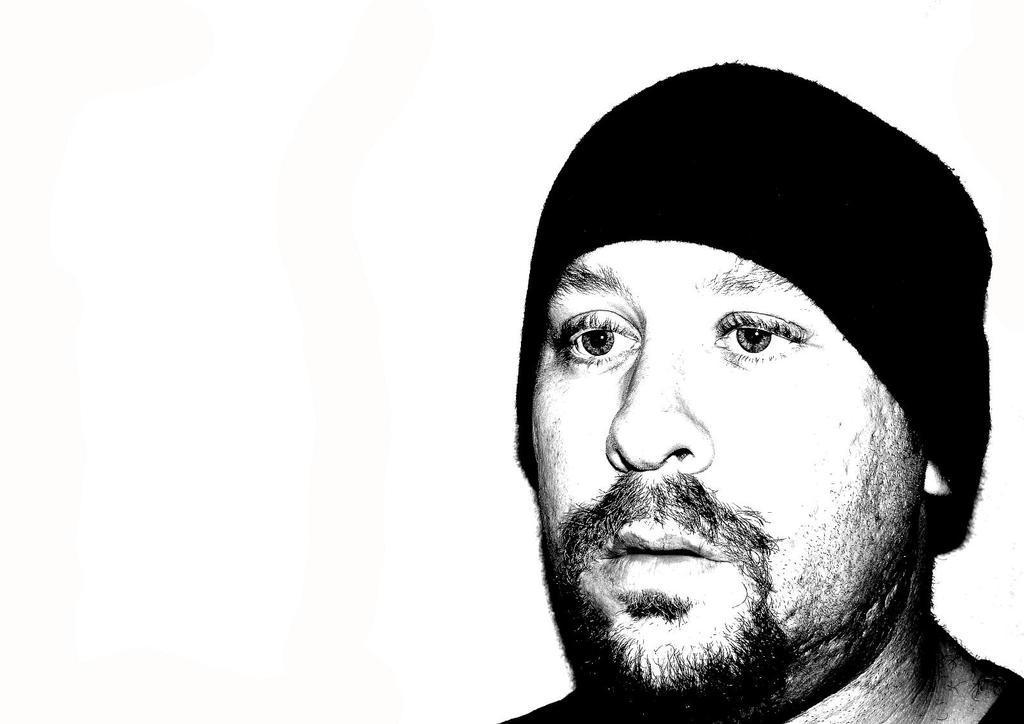Describe this image in one or two sentences. This is a black and white image in this image there is a person wearing a cap. 